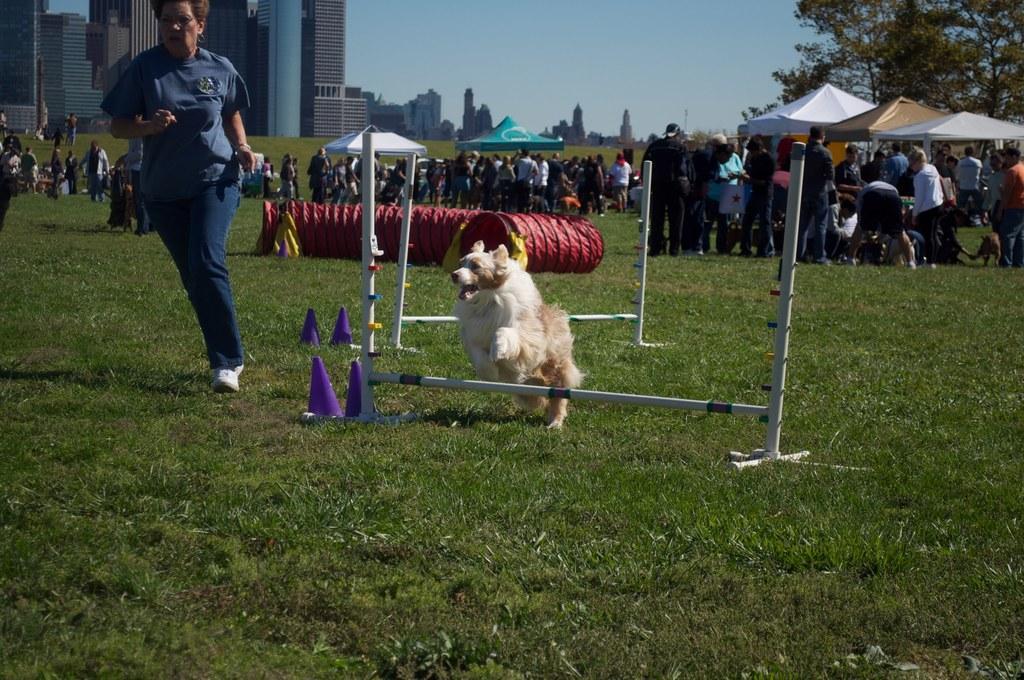Please provide a concise description of this image. Here we can see a dog jumping through an obstacle and beside it we can see a woman running on the grass and behind them we can see group of people standing and there are group of tents present and there are buildings and trees present 